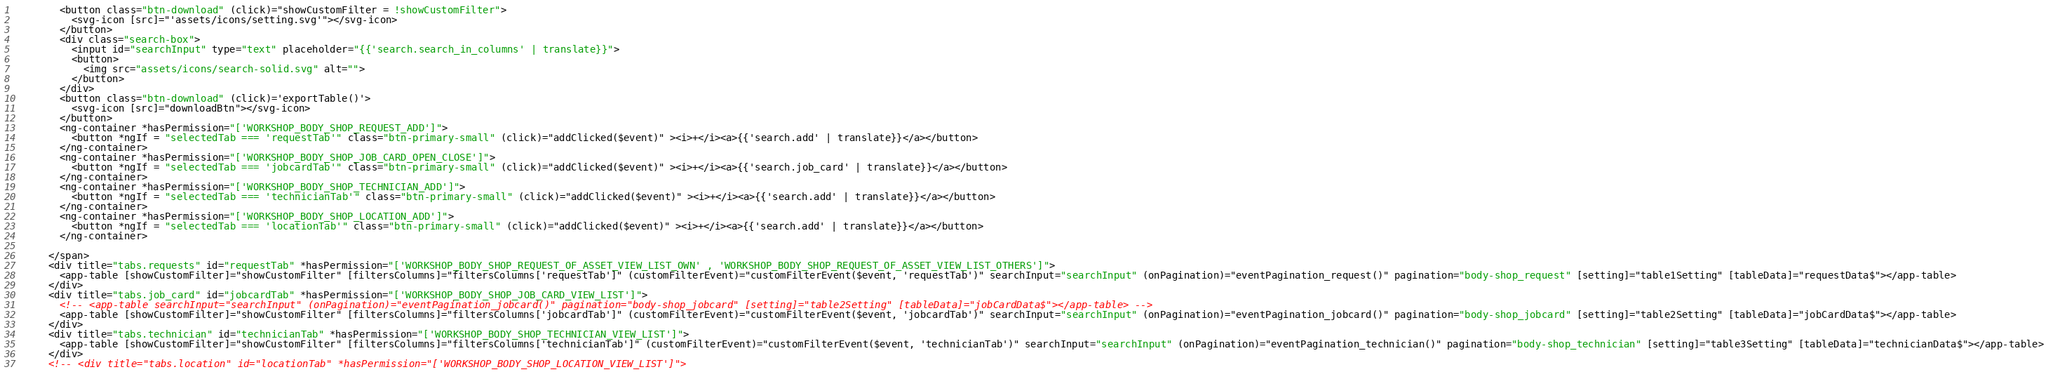Convert code to text. <code><loc_0><loc_0><loc_500><loc_500><_HTML_>        <button class="btn-download" (click)="showCustomFilter = !showCustomFilter">
          <svg-icon [src]="'assets/icons/setting.svg'"></svg-icon>
        </button>
        <div class="search-box">
          <input id="searchInput" type="text" placeholder="{{'search.search_in_columns' | translate}}">
          <button>
            <img src="assets/icons/search-solid.svg" alt="">
          </button>
        </div>
        <button class="btn-download" (click)='exportTable()'>
          <svg-icon [src]="downloadBtn"></svg-icon>
        </button>
        <ng-container *hasPermission="['WORKSHOP_BODY_SHOP_REQUEST_ADD']">
          <button *ngIf = "selectedTab === 'requestTab'" class="btn-primary-small" (click)="addClicked($event)" ><i>+</i><a>{{'search.add' | translate}}</a></button>
        </ng-container>
        <ng-container *hasPermission="['WORKSHOP_BODY_SHOP_JOB_CARD_OPEN_CLOSE']">
          <button *ngIf = "selectedTab === 'jobcardTab'" class="btn-primary-small" (click)="addClicked($event)" ><i>+</i><a>{{'search.job_card' | translate}}</a></button>
        </ng-container>
        <ng-container *hasPermission="['WORKSHOP_BODY_SHOP_TECHNICIAN_ADD']">
          <button *ngIf = "selectedTab === 'technicianTab'" class="btn-primary-small" (click)="addClicked($event)" ><i>+</i><a>{{'search.add' | translate}}</a></button>
        </ng-container>
        <ng-container *hasPermission="['WORKSHOP_BODY_SHOP_LOCATION_ADD']">
          <button *ngIf = "selectedTab === 'locationTab'" class="btn-primary-small" (click)="addClicked($event)" ><i>+</i><a>{{'search.add' | translate}}</a></button>
        </ng-container>

      </span>
      <div title="tabs.requests" id="requestTab" *hasPermission="['WORKSHOP_BODY_SHOP_REQUEST_OF_ASSET_VIEW_LIST_OWN' , 'WORKSHOP_BODY_SHOP_REQUEST_OF_ASSET_VIEW_LIST_OTHERS']">
        <app-table [showCustomFilter]="showCustomFilter" [filtersColumns]="filtersColumns['requestTab']" (customFilterEvent)="customFilterEvent($event, 'requestTab')" searchInput="searchInput" (onPagination)="eventPagination_request()" pagination="body-shop_request" [setting]="table1Setting" [tableData]="requestData$"></app-table>
      </div>
      <div title="tabs.job_card" id="jobcardTab" *hasPermission="['WORKSHOP_BODY_SHOP_JOB_CARD_VIEW_LIST']">
        <!-- <app-table searchInput="searchInput" (onPagination)="eventPagination_jobcard()" pagination="body-shop_jobcard" [setting]="table2Setting" [tableData]="jobCardData$"></app-table> -->
        <app-table [showCustomFilter]="showCustomFilter" [filtersColumns]="filtersColumns['jobcardTab']" (customFilterEvent)="customFilterEvent($event, 'jobcardTab')" searchInput="searchInput" (onPagination)="eventPagination_jobcard()" pagination="body-shop_jobcard" [setting]="table2Setting" [tableData]="jobCardData$"></app-table>
      </div>
      <div title="tabs.technician" id="technicianTab" *hasPermission="['WORKSHOP_BODY_SHOP_TECHNICIAN_VIEW_LIST']">
        <app-table [showCustomFilter]="showCustomFilter" [filtersColumns]="filtersColumns['technicianTab']" (customFilterEvent)="customFilterEvent($event, 'technicianTab')" searchInput="searchInput" (onPagination)="eventPagination_technician()" pagination="body-shop_technician" [setting]="table3Setting" [tableData]="technicianData$"></app-table>
      </div>
      <!-- <div title="tabs.location" id="locationTab" *hasPermission="['WORKSHOP_BODY_SHOP_LOCATION_VIEW_LIST']"></code> 